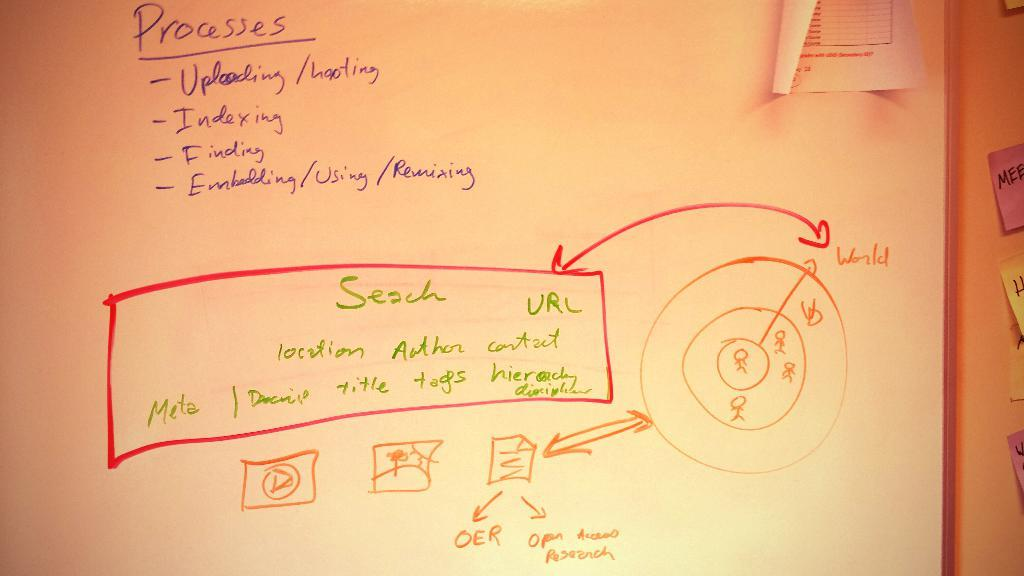<image>
Summarize the visual content of the image. Several phrases and quick sketches describing the Processes. 